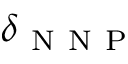<formula> <loc_0><loc_0><loc_500><loc_500>\delta _ { N N P }</formula> 